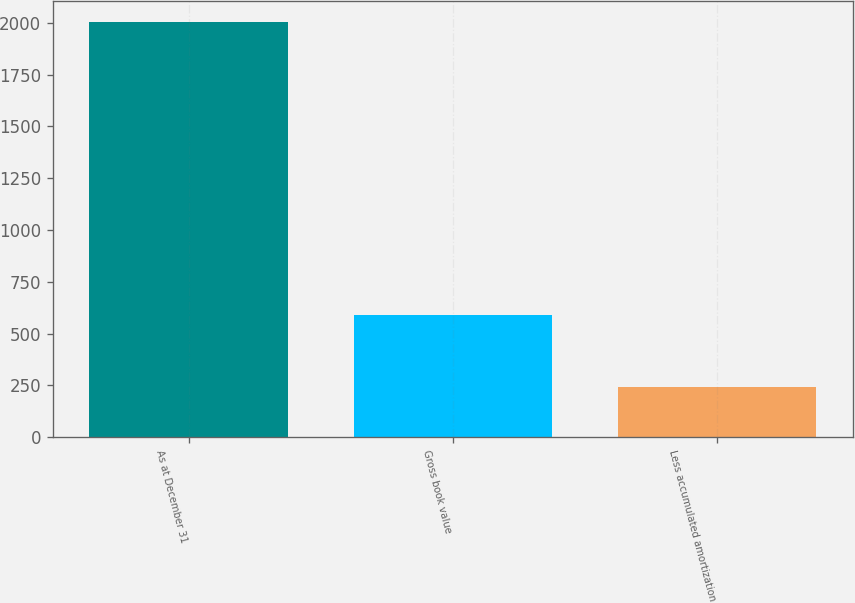Convert chart to OTSL. <chart><loc_0><loc_0><loc_500><loc_500><bar_chart><fcel>As at December 31<fcel>Gross book value<fcel>Less accumulated amortization<nl><fcel>2004<fcel>591<fcel>244<nl></chart> 